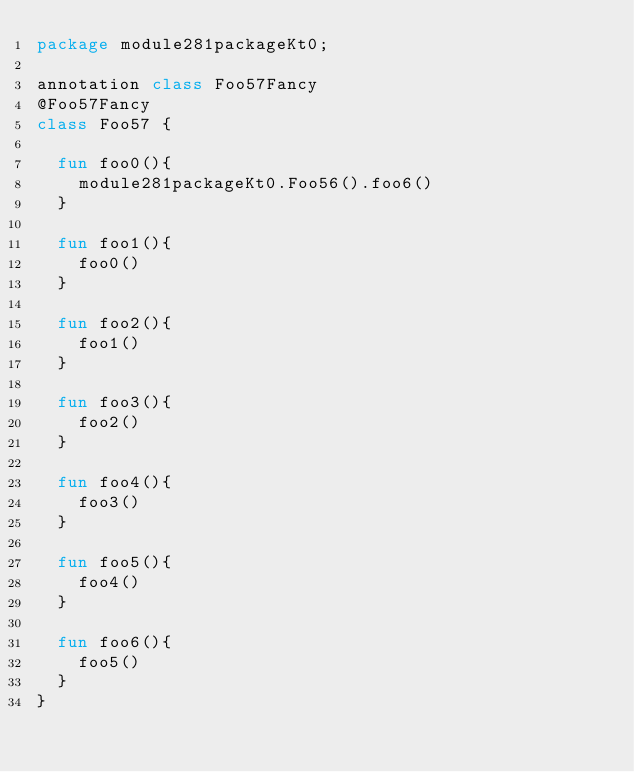<code> <loc_0><loc_0><loc_500><loc_500><_Kotlin_>package module281packageKt0;

annotation class Foo57Fancy
@Foo57Fancy
class Foo57 {

  fun foo0(){
    module281packageKt0.Foo56().foo6()
  }

  fun foo1(){
    foo0()
  }

  fun foo2(){
    foo1()
  }

  fun foo3(){
    foo2()
  }

  fun foo4(){
    foo3()
  }

  fun foo5(){
    foo4()
  }

  fun foo6(){
    foo5()
  }
}</code> 